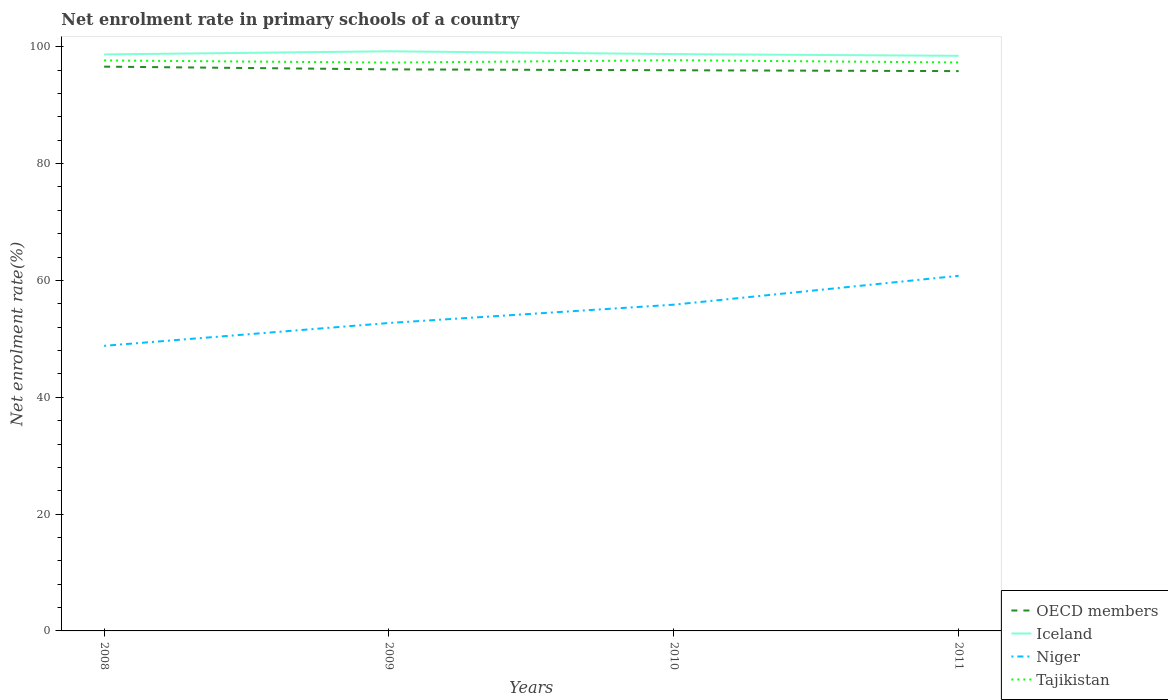How many different coloured lines are there?
Keep it short and to the point. 4. Is the number of lines equal to the number of legend labels?
Keep it short and to the point. Yes. Across all years, what is the maximum net enrolment rate in primary schools in OECD members?
Keep it short and to the point. 95.84. What is the total net enrolment rate in primary schools in Niger in the graph?
Your answer should be compact. -11.99. What is the difference between the highest and the second highest net enrolment rate in primary schools in Niger?
Make the answer very short. 11.99. What is the difference between the highest and the lowest net enrolment rate in primary schools in Niger?
Provide a succinct answer. 2. Is the net enrolment rate in primary schools in Tajikistan strictly greater than the net enrolment rate in primary schools in OECD members over the years?
Your response must be concise. No. What is the difference between two consecutive major ticks on the Y-axis?
Give a very brief answer. 20. Are the values on the major ticks of Y-axis written in scientific E-notation?
Your response must be concise. No. How are the legend labels stacked?
Provide a succinct answer. Vertical. What is the title of the graph?
Provide a succinct answer. Net enrolment rate in primary schools of a country. Does "East Asia (developing only)" appear as one of the legend labels in the graph?
Provide a succinct answer. No. What is the label or title of the Y-axis?
Your response must be concise. Net enrolment rate(%). What is the Net enrolment rate(%) of OECD members in 2008?
Ensure brevity in your answer.  96.6. What is the Net enrolment rate(%) in Iceland in 2008?
Your response must be concise. 98.69. What is the Net enrolment rate(%) in Niger in 2008?
Ensure brevity in your answer.  48.81. What is the Net enrolment rate(%) in Tajikistan in 2008?
Keep it short and to the point. 97.66. What is the Net enrolment rate(%) in OECD members in 2009?
Make the answer very short. 96.14. What is the Net enrolment rate(%) of Iceland in 2009?
Your answer should be very brief. 99.23. What is the Net enrolment rate(%) of Niger in 2009?
Keep it short and to the point. 52.72. What is the Net enrolment rate(%) of Tajikistan in 2009?
Offer a very short reply. 97.29. What is the Net enrolment rate(%) in OECD members in 2010?
Make the answer very short. 95.98. What is the Net enrolment rate(%) in Iceland in 2010?
Your answer should be compact. 98.75. What is the Net enrolment rate(%) of Niger in 2010?
Keep it short and to the point. 55.85. What is the Net enrolment rate(%) in Tajikistan in 2010?
Provide a succinct answer. 97.7. What is the Net enrolment rate(%) in OECD members in 2011?
Make the answer very short. 95.84. What is the Net enrolment rate(%) in Iceland in 2011?
Provide a short and direct response. 98.46. What is the Net enrolment rate(%) in Niger in 2011?
Offer a terse response. 60.79. What is the Net enrolment rate(%) of Tajikistan in 2011?
Your response must be concise. 97.31. Across all years, what is the maximum Net enrolment rate(%) of OECD members?
Your answer should be very brief. 96.6. Across all years, what is the maximum Net enrolment rate(%) of Iceland?
Your answer should be very brief. 99.23. Across all years, what is the maximum Net enrolment rate(%) of Niger?
Ensure brevity in your answer.  60.79. Across all years, what is the maximum Net enrolment rate(%) of Tajikistan?
Your response must be concise. 97.7. Across all years, what is the minimum Net enrolment rate(%) of OECD members?
Offer a terse response. 95.84. Across all years, what is the minimum Net enrolment rate(%) in Iceland?
Give a very brief answer. 98.46. Across all years, what is the minimum Net enrolment rate(%) in Niger?
Your answer should be very brief. 48.81. Across all years, what is the minimum Net enrolment rate(%) in Tajikistan?
Provide a succinct answer. 97.29. What is the total Net enrolment rate(%) in OECD members in the graph?
Your response must be concise. 384.56. What is the total Net enrolment rate(%) in Iceland in the graph?
Your answer should be compact. 395.13. What is the total Net enrolment rate(%) in Niger in the graph?
Offer a very short reply. 218.17. What is the total Net enrolment rate(%) in Tajikistan in the graph?
Provide a succinct answer. 389.97. What is the difference between the Net enrolment rate(%) of OECD members in 2008 and that in 2009?
Ensure brevity in your answer.  0.46. What is the difference between the Net enrolment rate(%) in Iceland in 2008 and that in 2009?
Give a very brief answer. -0.53. What is the difference between the Net enrolment rate(%) of Niger in 2008 and that in 2009?
Your response must be concise. -3.91. What is the difference between the Net enrolment rate(%) of Tajikistan in 2008 and that in 2009?
Keep it short and to the point. 0.37. What is the difference between the Net enrolment rate(%) in OECD members in 2008 and that in 2010?
Make the answer very short. 0.62. What is the difference between the Net enrolment rate(%) in Iceland in 2008 and that in 2010?
Provide a short and direct response. -0.06. What is the difference between the Net enrolment rate(%) of Niger in 2008 and that in 2010?
Give a very brief answer. -7.04. What is the difference between the Net enrolment rate(%) of Tajikistan in 2008 and that in 2010?
Ensure brevity in your answer.  -0.04. What is the difference between the Net enrolment rate(%) of OECD members in 2008 and that in 2011?
Provide a short and direct response. 0.76. What is the difference between the Net enrolment rate(%) of Iceland in 2008 and that in 2011?
Make the answer very short. 0.24. What is the difference between the Net enrolment rate(%) of Niger in 2008 and that in 2011?
Your answer should be compact. -11.99. What is the difference between the Net enrolment rate(%) in Tajikistan in 2008 and that in 2011?
Your answer should be very brief. 0.35. What is the difference between the Net enrolment rate(%) of OECD members in 2009 and that in 2010?
Keep it short and to the point. 0.15. What is the difference between the Net enrolment rate(%) in Iceland in 2009 and that in 2010?
Give a very brief answer. 0.48. What is the difference between the Net enrolment rate(%) of Niger in 2009 and that in 2010?
Offer a terse response. -3.13. What is the difference between the Net enrolment rate(%) in Tajikistan in 2009 and that in 2010?
Your response must be concise. -0.41. What is the difference between the Net enrolment rate(%) of OECD members in 2009 and that in 2011?
Offer a terse response. 0.3. What is the difference between the Net enrolment rate(%) of Iceland in 2009 and that in 2011?
Keep it short and to the point. 0.77. What is the difference between the Net enrolment rate(%) in Niger in 2009 and that in 2011?
Provide a succinct answer. -8.08. What is the difference between the Net enrolment rate(%) of Tajikistan in 2009 and that in 2011?
Offer a very short reply. -0.02. What is the difference between the Net enrolment rate(%) in OECD members in 2010 and that in 2011?
Ensure brevity in your answer.  0.15. What is the difference between the Net enrolment rate(%) in Iceland in 2010 and that in 2011?
Your answer should be compact. 0.29. What is the difference between the Net enrolment rate(%) of Niger in 2010 and that in 2011?
Your answer should be very brief. -4.94. What is the difference between the Net enrolment rate(%) of Tajikistan in 2010 and that in 2011?
Keep it short and to the point. 0.39. What is the difference between the Net enrolment rate(%) of OECD members in 2008 and the Net enrolment rate(%) of Iceland in 2009?
Your answer should be compact. -2.63. What is the difference between the Net enrolment rate(%) in OECD members in 2008 and the Net enrolment rate(%) in Niger in 2009?
Offer a terse response. 43.88. What is the difference between the Net enrolment rate(%) in OECD members in 2008 and the Net enrolment rate(%) in Tajikistan in 2009?
Provide a short and direct response. -0.69. What is the difference between the Net enrolment rate(%) in Iceland in 2008 and the Net enrolment rate(%) in Niger in 2009?
Your response must be concise. 45.98. What is the difference between the Net enrolment rate(%) in Iceland in 2008 and the Net enrolment rate(%) in Tajikistan in 2009?
Ensure brevity in your answer.  1.4. What is the difference between the Net enrolment rate(%) in Niger in 2008 and the Net enrolment rate(%) in Tajikistan in 2009?
Your answer should be compact. -48.49. What is the difference between the Net enrolment rate(%) in OECD members in 2008 and the Net enrolment rate(%) in Iceland in 2010?
Ensure brevity in your answer.  -2.15. What is the difference between the Net enrolment rate(%) of OECD members in 2008 and the Net enrolment rate(%) of Niger in 2010?
Offer a terse response. 40.75. What is the difference between the Net enrolment rate(%) in OECD members in 2008 and the Net enrolment rate(%) in Tajikistan in 2010?
Your answer should be very brief. -1.1. What is the difference between the Net enrolment rate(%) in Iceland in 2008 and the Net enrolment rate(%) in Niger in 2010?
Offer a very short reply. 42.84. What is the difference between the Net enrolment rate(%) of Iceland in 2008 and the Net enrolment rate(%) of Tajikistan in 2010?
Offer a very short reply. 0.99. What is the difference between the Net enrolment rate(%) of Niger in 2008 and the Net enrolment rate(%) of Tajikistan in 2010?
Ensure brevity in your answer.  -48.89. What is the difference between the Net enrolment rate(%) of OECD members in 2008 and the Net enrolment rate(%) of Iceland in 2011?
Your response must be concise. -1.86. What is the difference between the Net enrolment rate(%) in OECD members in 2008 and the Net enrolment rate(%) in Niger in 2011?
Keep it short and to the point. 35.81. What is the difference between the Net enrolment rate(%) in OECD members in 2008 and the Net enrolment rate(%) in Tajikistan in 2011?
Provide a succinct answer. -0.71. What is the difference between the Net enrolment rate(%) in Iceland in 2008 and the Net enrolment rate(%) in Niger in 2011?
Offer a terse response. 37.9. What is the difference between the Net enrolment rate(%) of Iceland in 2008 and the Net enrolment rate(%) of Tajikistan in 2011?
Provide a short and direct response. 1.38. What is the difference between the Net enrolment rate(%) of Niger in 2008 and the Net enrolment rate(%) of Tajikistan in 2011?
Offer a very short reply. -48.51. What is the difference between the Net enrolment rate(%) in OECD members in 2009 and the Net enrolment rate(%) in Iceland in 2010?
Ensure brevity in your answer.  -2.61. What is the difference between the Net enrolment rate(%) in OECD members in 2009 and the Net enrolment rate(%) in Niger in 2010?
Your answer should be very brief. 40.28. What is the difference between the Net enrolment rate(%) of OECD members in 2009 and the Net enrolment rate(%) of Tajikistan in 2010?
Your answer should be compact. -1.56. What is the difference between the Net enrolment rate(%) in Iceland in 2009 and the Net enrolment rate(%) in Niger in 2010?
Make the answer very short. 43.38. What is the difference between the Net enrolment rate(%) of Iceland in 2009 and the Net enrolment rate(%) of Tajikistan in 2010?
Make the answer very short. 1.53. What is the difference between the Net enrolment rate(%) in Niger in 2009 and the Net enrolment rate(%) in Tajikistan in 2010?
Your answer should be compact. -44.98. What is the difference between the Net enrolment rate(%) of OECD members in 2009 and the Net enrolment rate(%) of Iceland in 2011?
Your answer should be compact. -2.32. What is the difference between the Net enrolment rate(%) of OECD members in 2009 and the Net enrolment rate(%) of Niger in 2011?
Make the answer very short. 35.34. What is the difference between the Net enrolment rate(%) of OECD members in 2009 and the Net enrolment rate(%) of Tajikistan in 2011?
Your answer should be compact. -1.18. What is the difference between the Net enrolment rate(%) of Iceland in 2009 and the Net enrolment rate(%) of Niger in 2011?
Your response must be concise. 38.43. What is the difference between the Net enrolment rate(%) in Iceland in 2009 and the Net enrolment rate(%) in Tajikistan in 2011?
Ensure brevity in your answer.  1.91. What is the difference between the Net enrolment rate(%) in Niger in 2009 and the Net enrolment rate(%) in Tajikistan in 2011?
Offer a very short reply. -44.6. What is the difference between the Net enrolment rate(%) in OECD members in 2010 and the Net enrolment rate(%) in Iceland in 2011?
Provide a short and direct response. -2.47. What is the difference between the Net enrolment rate(%) in OECD members in 2010 and the Net enrolment rate(%) in Niger in 2011?
Provide a short and direct response. 35.19. What is the difference between the Net enrolment rate(%) in OECD members in 2010 and the Net enrolment rate(%) in Tajikistan in 2011?
Your answer should be compact. -1.33. What is the difference between the Net enrolment rate(%) in Iceland in 2010 and the Net enrolment rate(%) in Niger in 2011?
Your answer should be very brief. 37.96. What is the difference between the Net enrolment rate(%) of Iceland in 2010 and the Net enrolment rate(%) of Tajikistan in 2011?
Your answer should be compact. 1.44. What is the difference between the Net enrolment rate(%) in Niger in 2010 and the Net enrolment rate(%) in Tajikistan in 2011?
Your answer should be compact. -41.46. What is the average Net enrolment rate(%) of OECD members per year?
Provide a short and direct response. 96.14. What is the average Net enrolment rate(%) of Iceland per year?
Your response must be concise. 98.78. What is the average Net enrolment rate(%) in Niger per year?
Ensure brevity in your answer.  54.54. What is the average Net enrolment rate(%) in Tajikistan per year?
Give a very brief answer. 97.49. In the year 2008, what is the difference between the Net enrolment rate(%) in OECD members and Net enrolment rate(%) in Iceland?
Your answer should be compact. -2.09. In the year 2008, what is the difference between the Net enrolment rate(%) of OECD members and Net enrolment rate(%) of Niger?
Your answer should be very brief. 47.79. In the year 2008, what is the difference between the Net enrolment rate(%) in OECD members and Net enrolment rate(%) in Tajikistan?
Ensure brevity in your answer.  -1.06. In the year 2008, what is the difference between the Net enrolment rate(%) of Iceland and Net enrolment rate(%) of Niger?
Give a very brief answer. 49.89. In the year 2008, what is the difference between the Net enrolment rate(%) of Iceland and Net enrolment rate(%) of Tajikistan?
Offer a terse response. 1.03. In the year 2008, what is the difference between the Net enrolment rate(%) of Niger and Net enrolment rate(%) of Tajikistan?
Ensure brevity in your answer.  -48.85. In the year 2009, what is the difference between the Net enrolment rate(%) in OECD members and Net enrolment rate(%) in Iceland?
Provide a short and direct response. -3.09. In the year 2009, what is the difference between the Net enrolment rate(%) of OECD members and Net enrolment rate(%) of Niger?
Provide a succinct answer. 43.42. In the year 2009, what is the difference between the Net enrolment rate(%) in OECD members and Net enrolment rate(%) in Tajikistan?
Your answer should be compact. -1.16. In the year 2009, what is the difference between the Net enrolment rate(%) of Iceland and Net enrolment rate(%) of Niger?
Offer a terse response. 46.51. In the year 2009, what is the difference between the Net enrolment rate(%) in Iceland and Net enrolment rate(%) in Tajikistan?
Offer a very short reply. 1.93. In the year 2009, what is the difference between the Net enrolment rate(%) of Niger and Net enrolment rate(%) of Tajikistan?
Ensure brevity in your answer.  -44.58. In the year 2010, what is the difference between the Net enrolment rate(%) of OECD members and Net enrolment rate(%) of Iceland?
Your response must be concise. -2.77. In the year 2010, what is the difference between the Net enrolment rate(%) in OECD members and Net enrolment rate(%) in Niger?
Keep it short and to the point. 40.13. In the year 2010, what is the difference between the Net enrolment rate(%) in OECD members and Net enrolment rate(%) in Tajikistan?
Your response must be concise. -1.72. In the year 2010, what is the difference between the Net enrolment rate(%) of Iceland and Net enrolment rate(%) of Niger?
Keep it short and to the point. 42.9. In the year 2010, what is the difference between the Net enrolment rate(%) in Iceland and Net enrolment rate(%) in Tajikistan?
Ensure brevity in your answer.  1.05. In the year 2010, what is the difference between the Net enrolment rate(%) in Niger and Net enrolment rate(%) in Tajikistan?
Offer a terse response. -41.85. In the year 2011, what is the difference between the Net enrolment rate(%) in OECD members and Net enrolment rate(%) in Iceland?
Your answer should be very brief. -2.62. In the year 2011, what is the difference between the Net enrolment rate(%) of OECD members and Net enrolment rate(%) of Niger?
Provide a short and direct response. 35.04. In the year 2011, what is the difference between the Net enrolment rate(%) of OECD members and Net enrolment rate(%) of Tajikistan?
Make the answer very short. -1.48. In the year 2011, what is the difference between the Net enrolment rate(%) of Iceland and Net enrolment rate(%) of Niger?
Keep it short and to the point. 37.66. In the year 2011, what is the difference between the Net enrolment rate(%) in Iceland and Net enrolment rate(%) in Tajikistan?
Keep it short and to the point. 1.14. In the year 2011, what is the difference between the Net enrolment rate(%) of Niger and Net enrolment rate(%) of Tajikistan?
Your response must be concise. -36.52. What is the ratio of the Net enrolment rate(%) of OECD members in 2008 to that in 2009?
Offer a very short reply. 1. What is the ratio of the Net enrolment rate(%) in Niger in 2008 to that in 2009?
Your answer should be very brief. 0.93. What is the ratio of the Net enrolment rate(%) in OECD members in 2008 to that in 2010?
Ensure brevity in your answer.  1.01. What is the ratio of the Net enrolment rate(%) of Niger in 2008 to that in 2010?
Ensure brevity in your answer.  0.87. What is the ratio of the Net enrolment rate(%) in OECD members in 2008 to that in 2011?
Offer a terse response. 1.01. What is the ratio of the Net enrolment rate(%) of Iceland in 2008 to that in 2011?
Your answer should be very brief. 1. What is the ratio of the Net enrolment rate(%) in Niger in 2008 to that in 2011?
Offer a terse response. 0.8. What is the ratio of the Net enrolment rate(%) in Tajikistan in 2008 to that in 2011?
Provide a succinct answer. 1. What is the ratio of the Net enrolment rate(%) in OECD members in 2009 to that in 2010?
Offer a very short reply. 1. What is the ratio of the Net enrolment rate(%) in Niger in 2009 to that in 2010?
Offer a terse response. 0.94. What is the ratio of the Net enrolment rate(%) in Niger in 2009 to that in 2011?
Offer a terse response. 0.87. What is the ratio of the Net enrolment rate(%) of Tajikistan in 2009 to that in 2011?
Offer a terse response. 1. What is the ratio of the Net enrolment rate(%) of Niger in 2010 to that in 2011?
Give a very brief answer. 0.92. What is the ratio of the Net enrolment rate(%) of Tajikistan in 2010 to that in 2011?
Offer a very short reply. 1. What is the difference between the highest and the second highest Net enrolment rate(%) in OECD members?
Provide a short and direct response. 0.46. What is the difference between the highest and the second highest Net enrolment rate(%) in Iceland?
Keep it short and to the point. 0.48. What is the difference between the highest and the second highest Net enrolment rate(%) in Niger?
Your answer should be compact. 4.94. What is the difference between the highest and the second highest Net enrolment rate(%) of Tajikistan?
Give a very brief answer. 0.04. What is the difference between the highest and the lowest Net enrolment rate(%) in OECD members?
Make the answer very short. 0.76. What is the difference between the highest and the lowest Net enrolment rate(%) of Iceland?
Provide a succinct answer. 0.77. What is the difference between the highest and the lowest Net enrolment rate(%) of Niger?
Ensure brevity in your answer.  11.99. What is the difference between the highest and the lowest Net enrolment rate(%) of Tajikistan?
Offer a very short reply. 0.41. 